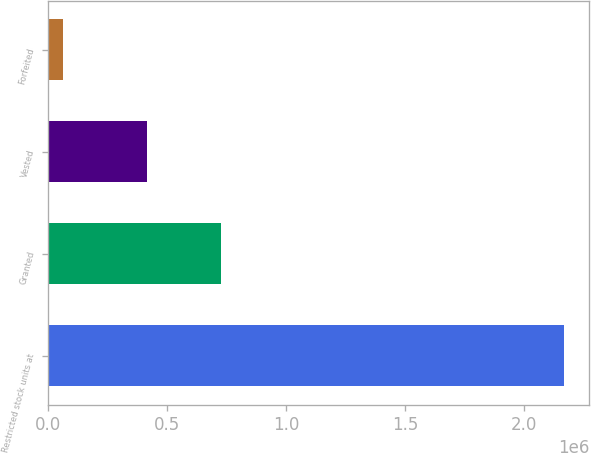Convert chart. <chart><loc_0><loc_0><loc_500><loc_500><bar_chart><fcel>Restricted stock units at<fcel>Granted<fcel>Vested<fcel>Forfeited<nl><fcel>2.16622e+06<fcel>727300<fcel>416755<fcel>63163<nl></chart> 